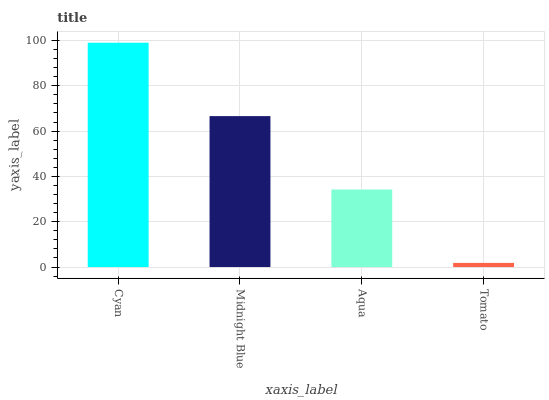Is Tomato the minimum?
Answer yes or no. Yes. Is Cyan the maximum?
Answer yes or no. Yes. Is Midnight Blue the minimum?
Answer yes or no. No. Is Midnight Blue the maximum?
Answer yes or no. No. Is Cyan greater than Midnight Blue?
Answer yes or no. Yes. Is Midnight Blue less than Cyan?
Answer yes or no. Yes. Is Midnight Blue greater than Cyan?
Answer yes or no. No. Is Cyan less than Midnight Blue?
Answer yes or no. No. Is Midnight Blue the high median?
Answer yes or no. Yes. Is Aqua the low median?
Answer yes or no. Yes. Is Aqua the high median?
Answer yes or no. No. Is Cyan the low median?
Answer yes or no. No. 